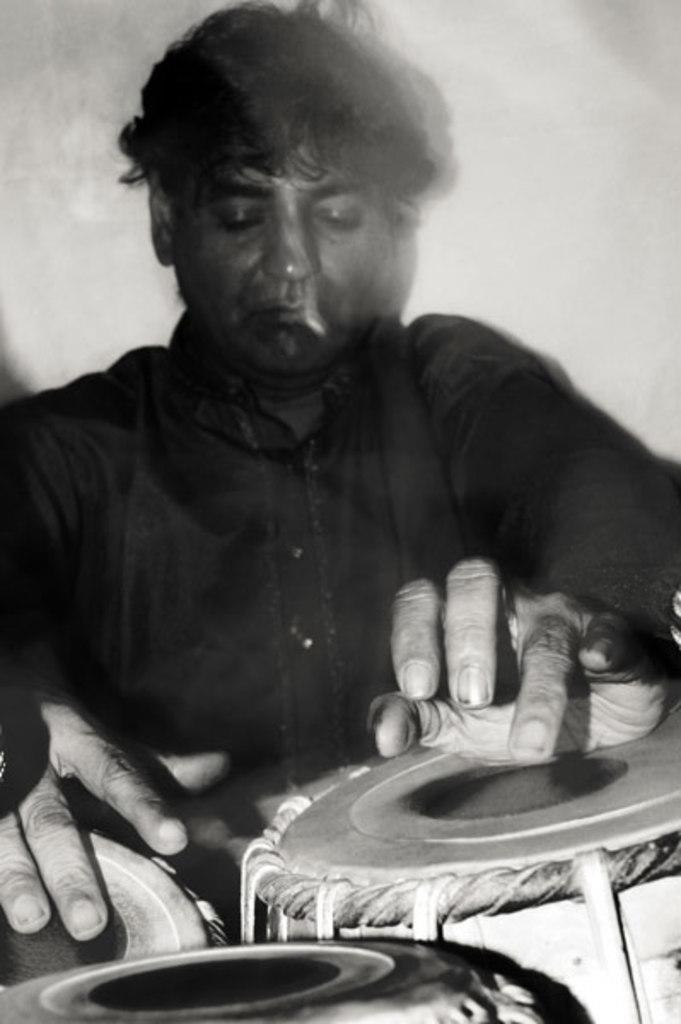What is the main subject of the image? The main subject of the image is a man. What is the man doing in the image? The man is sitting and playing drums. How many ladybugs can be seen on the drum set in the image? There are no ladybugs present in the image. What degree does the man have in drumming, as seen in the image? The image does not provide information about the man's qualifications or degrees in drumming. 